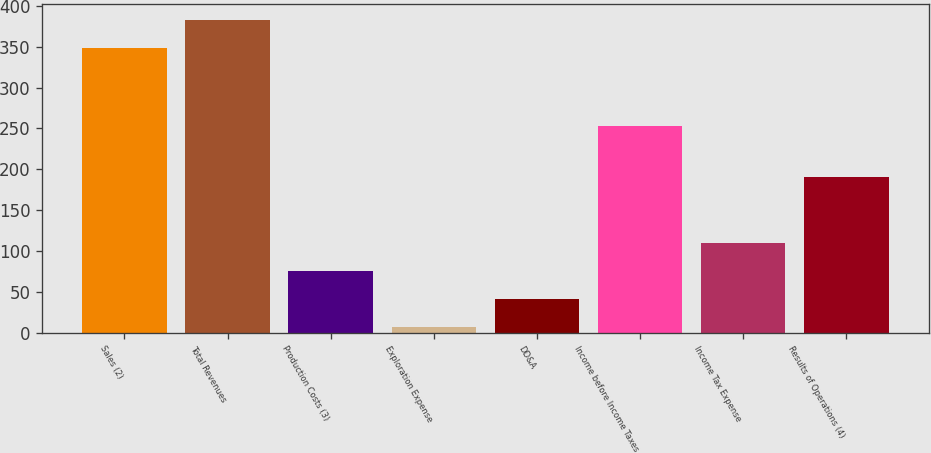Convert chart. <chart><loc_0><loc_0><loc_500><loc_500><bar_chart><fcel>Sales (2)<fcel>Total Revenues<fcel>Production Costs (3)<fcel>Exploration Expense<fcel>DD&A<fcel>Income before Income Taxes<fcel>Income Tax Expense<fcel>Results of Operations (4)<nl><fcel>349<fcel>383.2<fcel>75.4<fcel>7<fcel>41.2<fcel>253<fcel>109.6<fcel>190<nl></chart> 